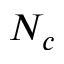Convert formula to latex. <formula><loc_0><loc_0><loc_500><loc_500>N _ { c }</formula> 